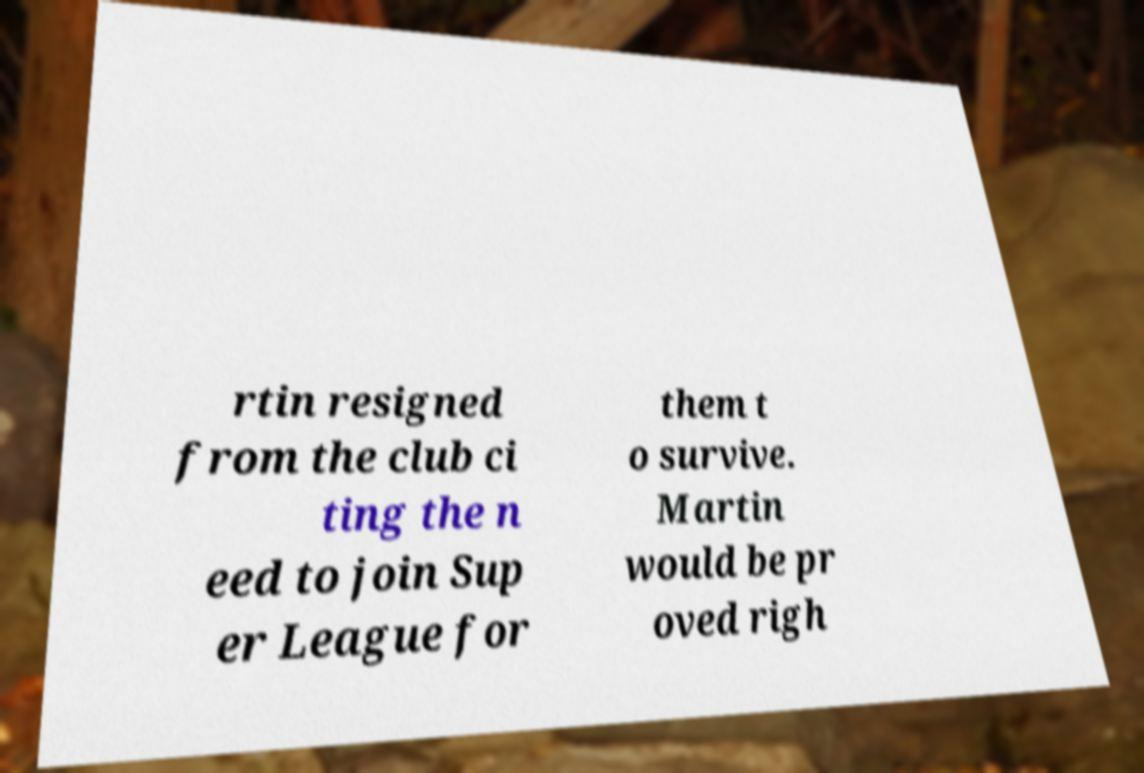I need the written content from this picture converted into text. Can you do that? rtin resigned from the club ci ting the n eed to join Sup er League for them t o survive. Martin would be pr oved righ 